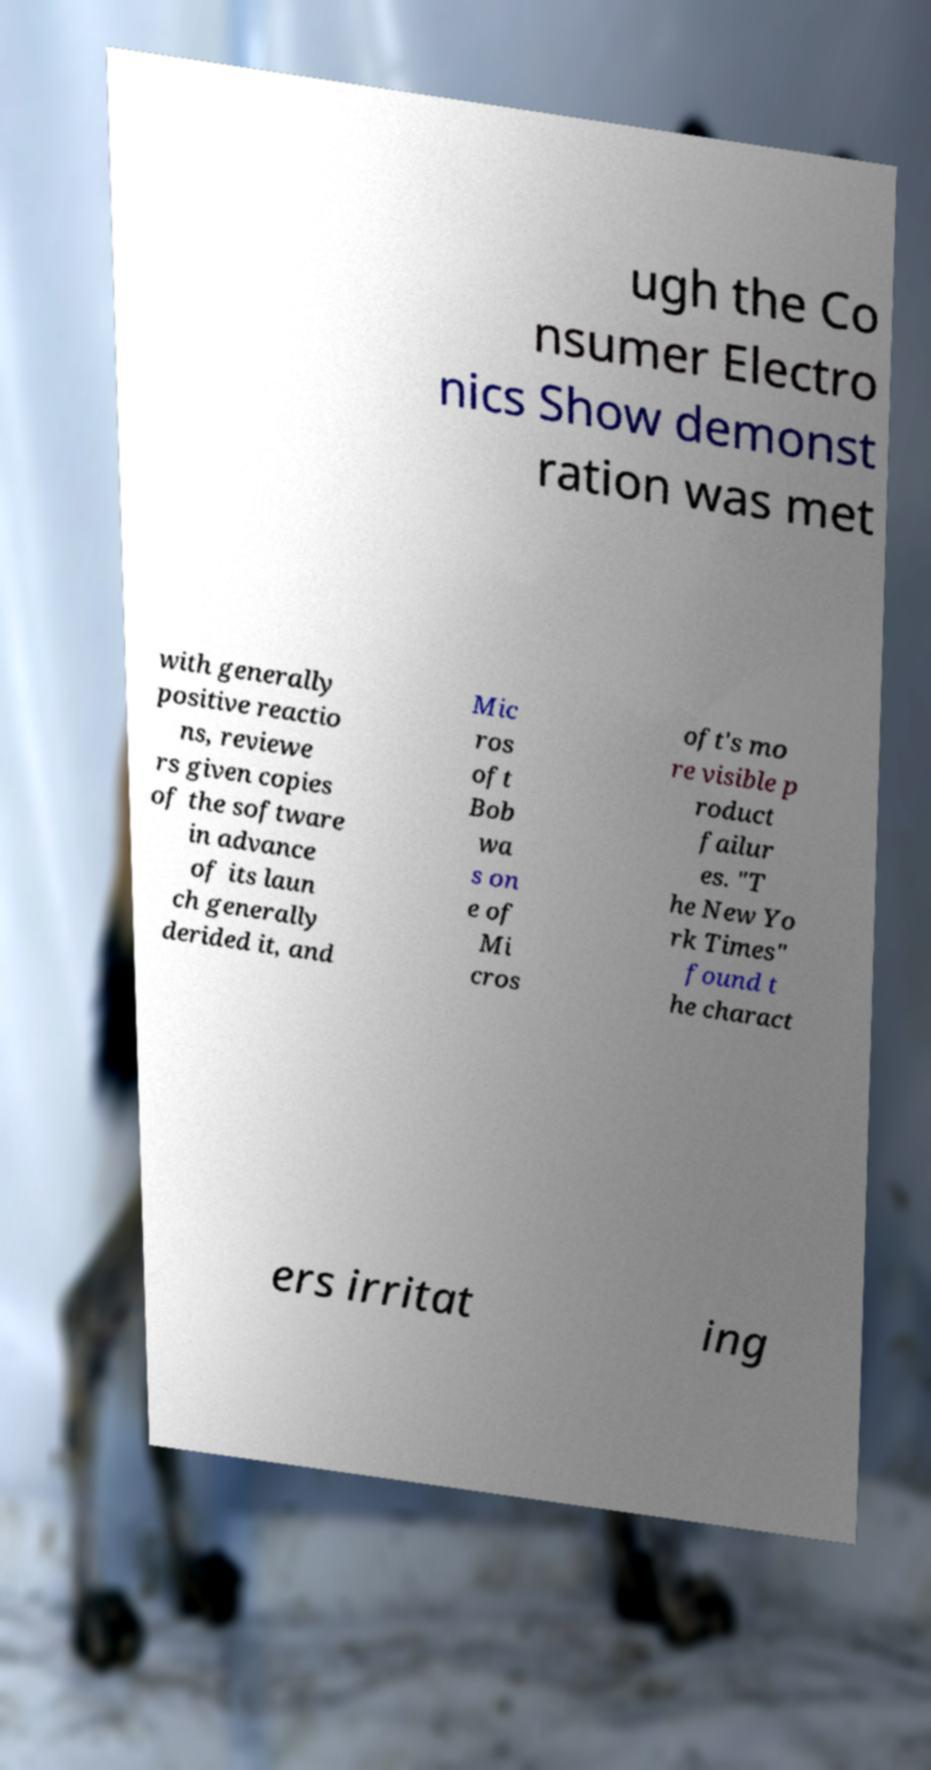For documentation purposes, I need the text within this image transcribed. Could you provide that? ugh the Co nsumer Electro nics Show demonst ration was met with generally positive reactio ns, reviewe rs given copies of the software in advance of its laun ch generally derided it, and Mic ros oft Bob wa s on e of Mi cros oft's mo re visible p roduct failur es. "T he New Yo rk Times" found t he charact ers irritat ing 